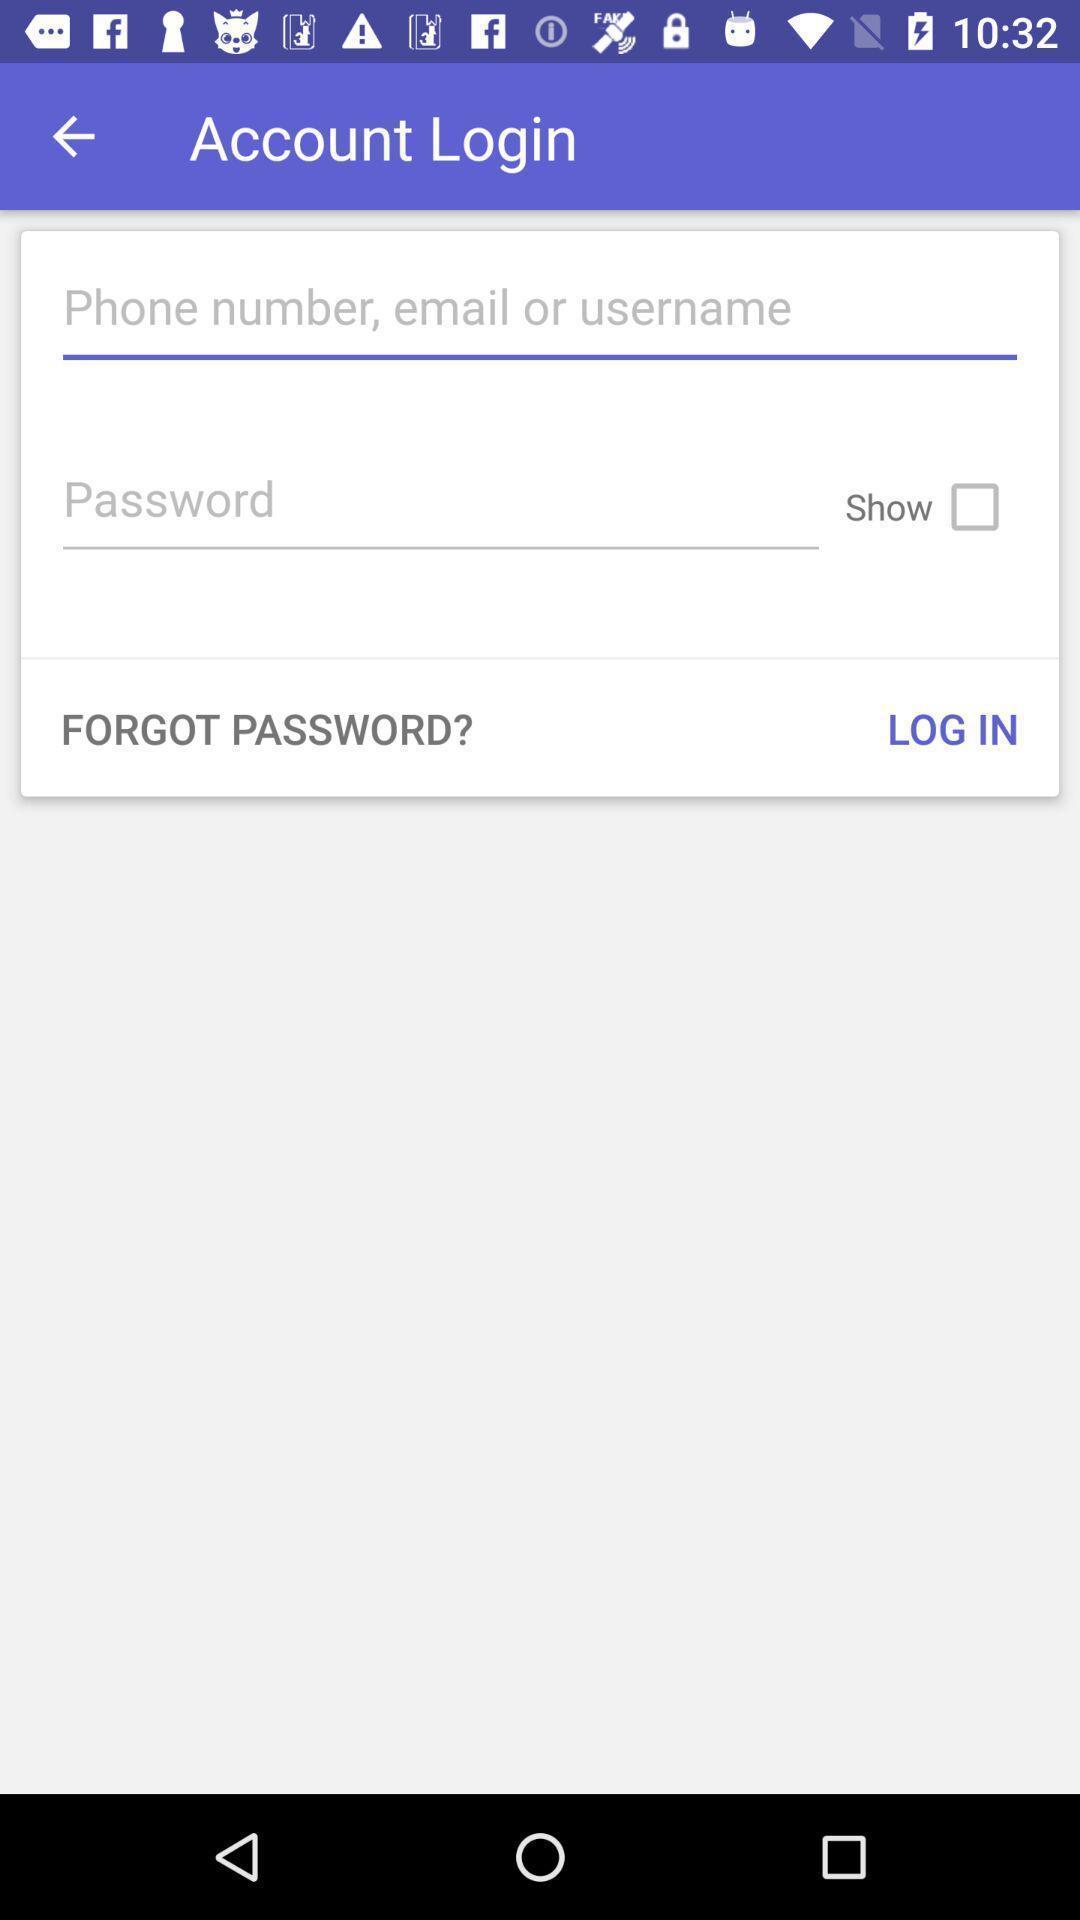Give me a narrative description of this picture. Page shown log in details for a free communication app. 